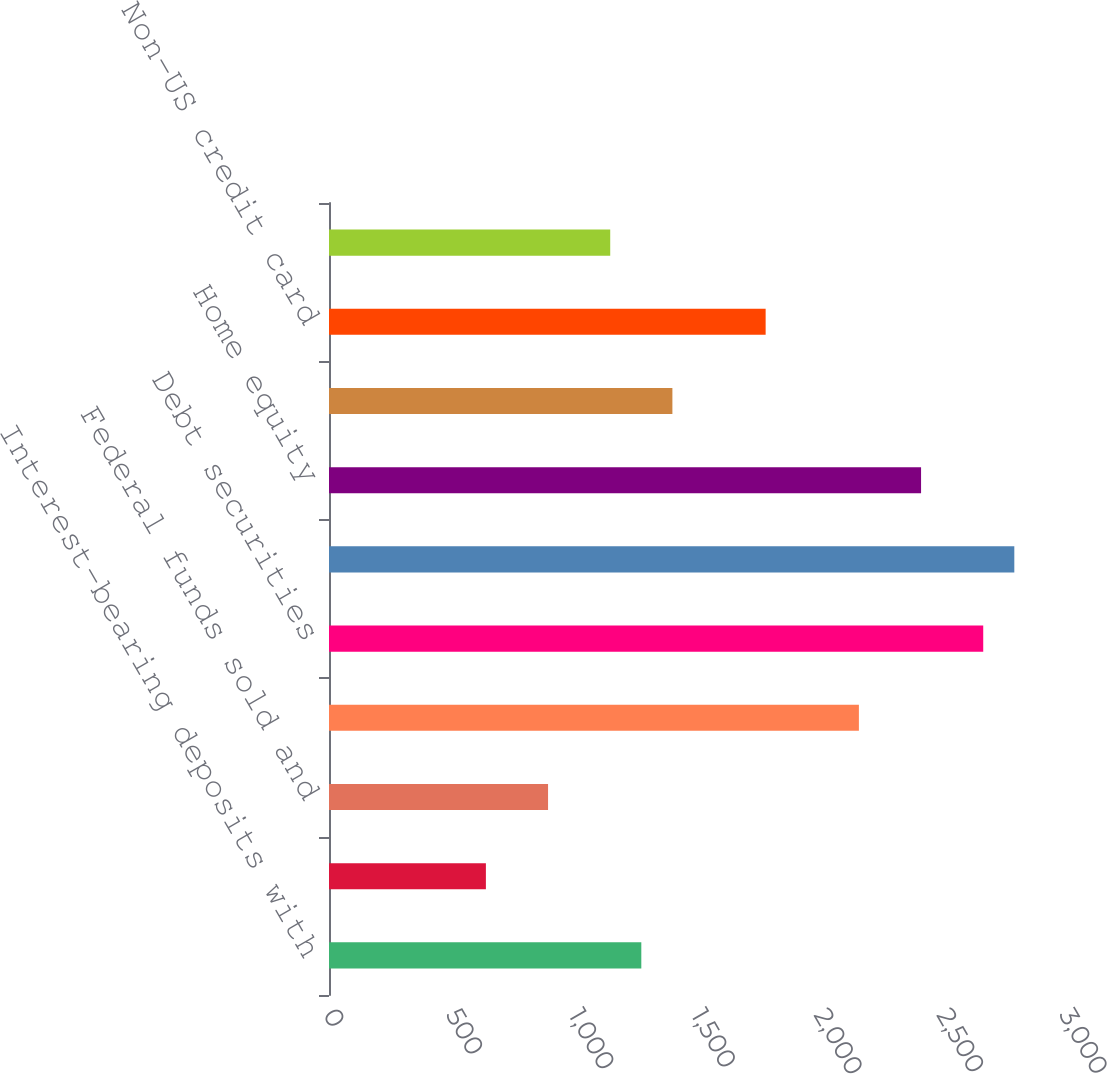Convert chart to OTSL. <chart><loc_0><loc_0><loc_500><loc_500><bar_chart><fcel>Interest-bearing deposits with<fcel>Time deposits placed and other<fcel>Federal funds sold and<fcel>Trading account assets<fcel>Debt securities<fcel>Residential mortgage<fcel>Home equity<fcel>US credit card<fcel>Non-US credit card<fcel>Direct/Indirect consumer<nl><fcel>1273<fcel>639.5<fcel>892.9<fcel>2159.9<fcel>2666.7<fcel>2793.4<fcel>2413.3<fcel>1399.7<fcel>1779.8<fcel>1146.3<nl></chart> 